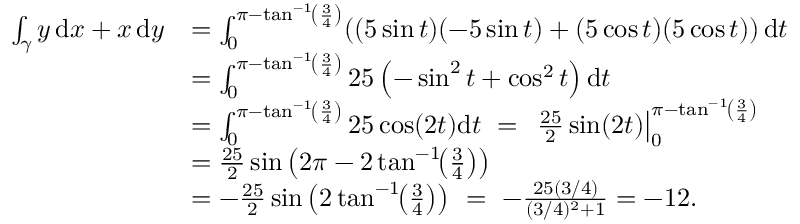<formula> <loc_0><loc_0><loc_500><loc_500>{ \begin{array} { r l } { \int _ { \gamma } y \, d x + x \, d y } & { = \int _ { 0 } ^ { \pi - \tan ^ { - 1 } \, \left ( { \frac { 3 } { 4 } } \right ) } ( ( 5 \sin t ) ( - 5 \sin t ) + ( 5 \cos t ) ( 5 \cos t ) ) \, d t } \\ & { = \int _ { 0 } ^ { \pi - \tan ^ { - 1 } \, \left ( { \frac { 3 } { 4 } } \right ) } 2 5 \left ( - \sin ^ { 2 } t + \cos ^ { 2 } t \right ) d t } \\ & { = \int _ { 0 } ^ { \pi - \tan ^ { - 1 } \, \left ( { \frac { 3 } { 4 } } \right ) } 2 5 \cos ( 2 t ) d t \ = \ { \frac { 2 5 } { 2 } } \sin ( 2 t ) \right | _ { 0 } ^ { \pi - \tan ^ { - 1 } \, \left ( { \frac { 3 } { 4 } } \right ) } } \\ & { = { \frac { 2 5 } { 2 } } \sin \left ( 2 \pi - 2 \tan ^ { - 1 } \, \left ( { \frac { 3 } { 4 } } \right ) \right ) } \\ & { = - { \frac { 2 5 } { 2 } } \sin \left ( 2 \tan ^ { - 1 } \, \left ( { \frac { 3 } { 4 } } \right ) \right ) \ = \ - { \frac { 2 5 ( 3 / 4 ) } { ( 3 / 4 ) ^ { 2 } + 1 } } = - 1 2 . } \end{array} }</formula> 